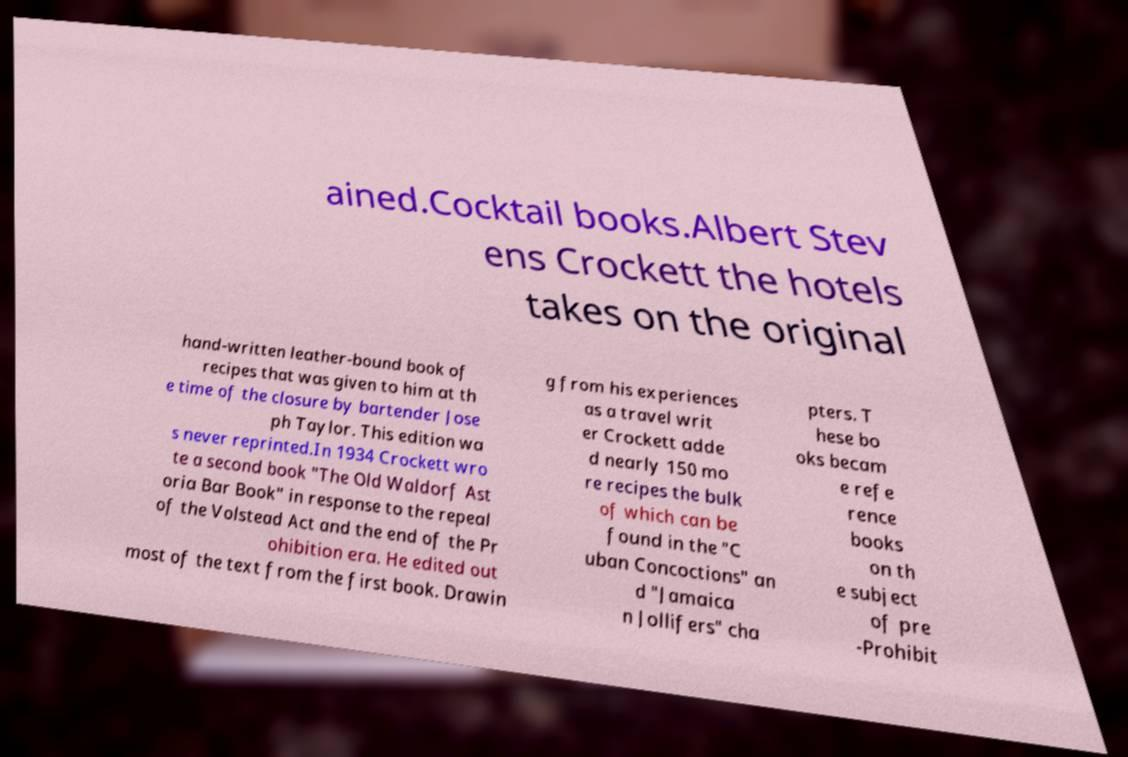I need the written content from this picture converted into text. Can you do that? ained.Cocktail books.Albert Stev ens Crockett the hotels takes on the original hand-written leather-bound book of recipes that was given to him at th e time of the closure by bartender Jose ph Taylor. This edition wa s never reprinted.In 1934 Crockett wro te a second book "The Old Waldorf Ast oria Bar Book" in response to the repeal of the Volstead Act and the end of the Pr ohibition era. He edited out most of the text from the first book. Drawin g from his experiences as a travel writ er Crockett adde d nearly 150 mo re recipes the bulk of which can be found in the "C uban Concoctions" an d "Jamaica n Jollifers" cha pters. T hese bo oks becam e refe rence books on th e subject of pre -Prohibit 